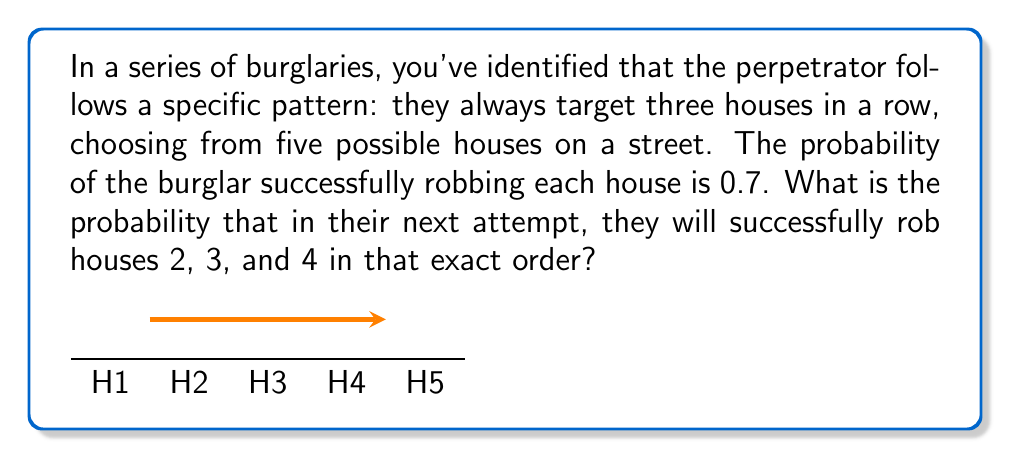Can you solve this math problem? Let's break this down step-by-step:

1) The question asks for a specific sequence of events: successfully robbing houses 2, 3, and 4 in that exact order.

2) For each house, the probability of a successful robbery is 0.7. This means the probability of failure for each house is 1 - 0.7 = 0.3.

3) For the sequence to occur as specified, we need three successful robberies in a row. In probability theory, when we want multiple independent events to all occur, we multiply their individual probabilities.

4) The probability of this specific sequence is therefore:

   $$P(\text{Success H2} \cap \text{Success H3} \cap \text{Success H4}) = 0.7 \times 0.7 \times 0.7$$

5) Let's calculate this:

   $$0.7 \times 0.7 \times 0.7 = 0.7^3 = 0.343$$

6) We can express this as a fraction if needed:

   $$0.343 = \frac{343}{1000}$$

Therefore, the probability of the burglar successfully robbing houses 2, 3, and 4 in that exact order is 0.343 or 34.3%.
Answer: $0.343$ or $\frac{343}{1000}$ or $34.3\%$ 